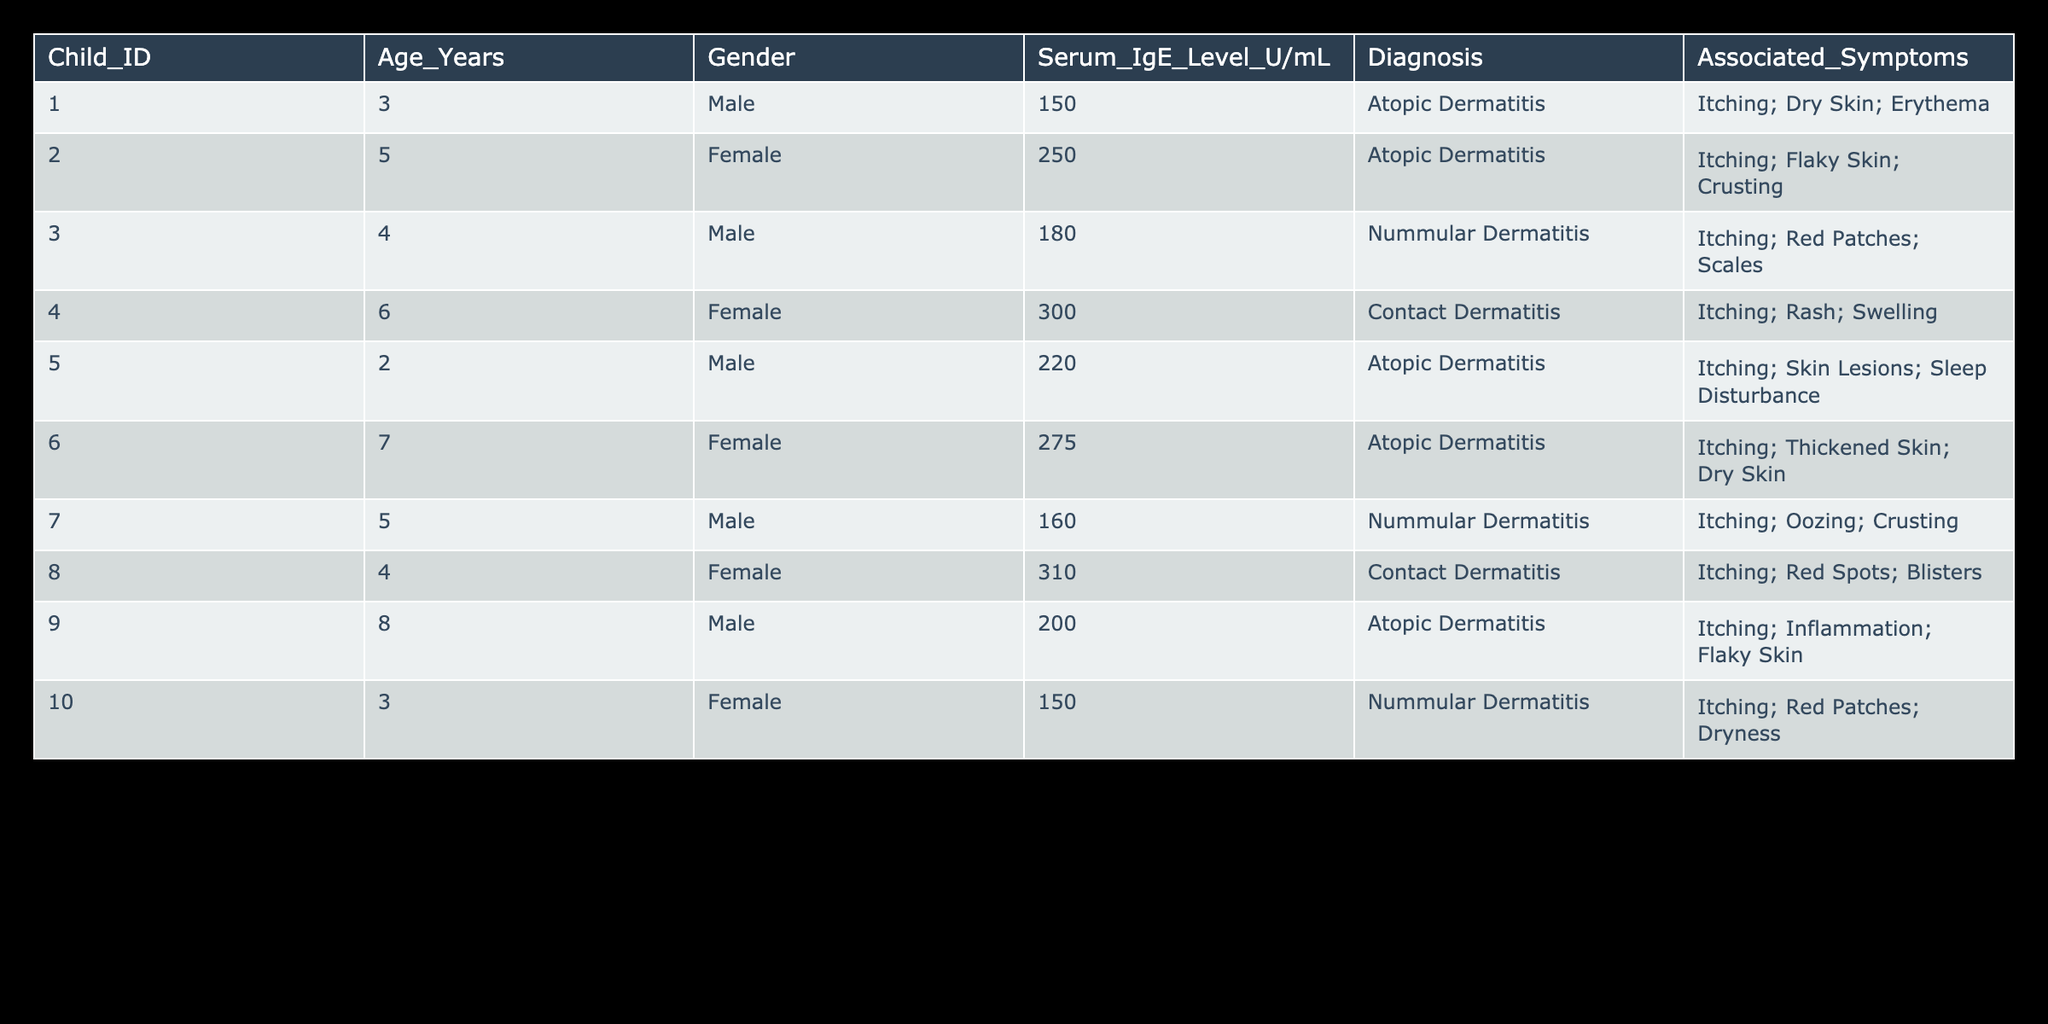What is the Serum IgE level of Child ID 002? The Serum IgE level is in the column labeled "Serum_IgE_Level_U/mL" for Child ID 002. Looking at that row in the table, the value is 250.
Answer: 250 Which gender has the highest average Serum IgE level? First, we need to separate the children by gender and tally the Serum IgE levels. The male children (IDs 001, 003, 005, 007, 009) have levels of 150, 180, 220, 160, and 200, respectively, which sum to 910 and average to 182. The female children (IDs 002, 004, 006, 008, 010) have levels of 250, 300, 275, 310, and 150, which sum to 1285 and average to 257. The average Serum IgE level for females is higher.
Answer: Female Are there any children with Serum IgE levels above 300? To answer this, we check the "Serum_IgE_Level_U/mL" column for values above 300. The only values are 310 for Child ID 008. Thus, there is at least one child with levels above 300.
Answer: Yes What are the associated symptoms for the child with the lowest Serum IgE level? First, identify the lowest Serum IgE level from the table, which is 150 for Child IDs 001 and 010. Both children have a level of 150; we can check their symptoms. Child ID 001 reports "Itching; Dry Skin; Erythema" while Child ID 010 lists "Itching; Red Patches; Dryness." Therefore, the associated symptoms can be mentioned for both.
Answer: Itching; Dry Skin; Erythema and Itching; Red Patches; Dryness How many children exhibit the symptom of "Itching"? We will check each row for the presence of "Itching" in the "Associated_Symptoms" column. By scanning through the data, we find that all children (IDs 001, 002, 003, 004, 005, 006, 007, 008, 009, and 010) have this symptom, totaling 10 children.
Answer: 10 